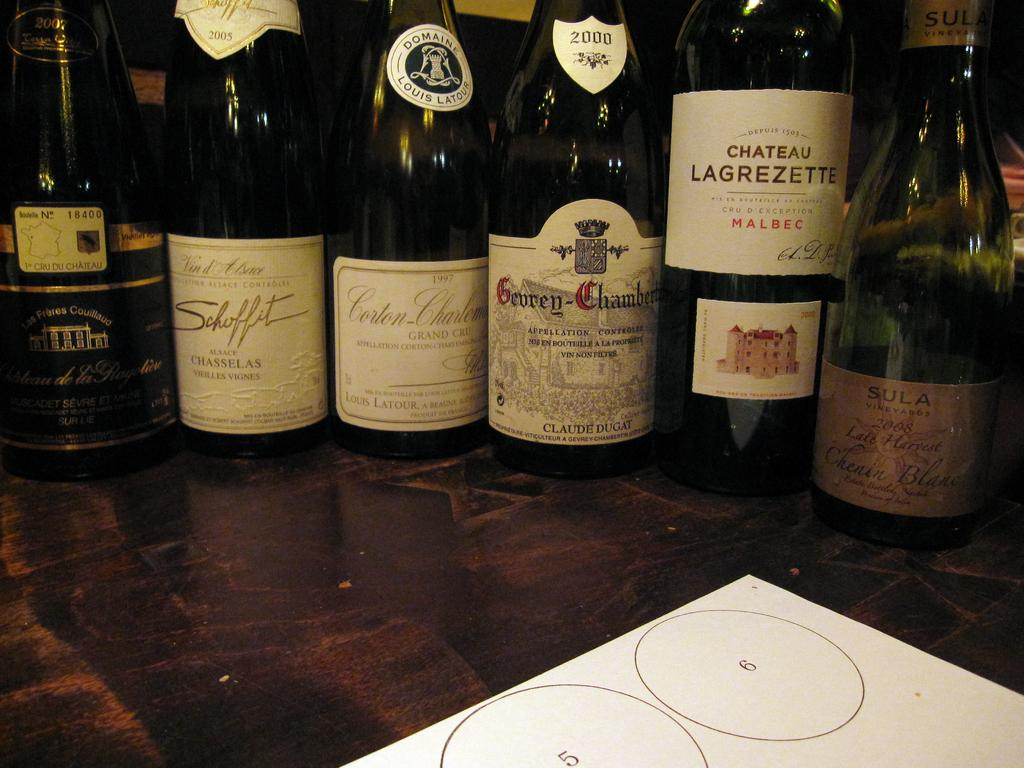<image>
Give a short and clear explanation of the subsequent image. WIne bottles next to one another with one whose label says Chateau Lagrezette. 